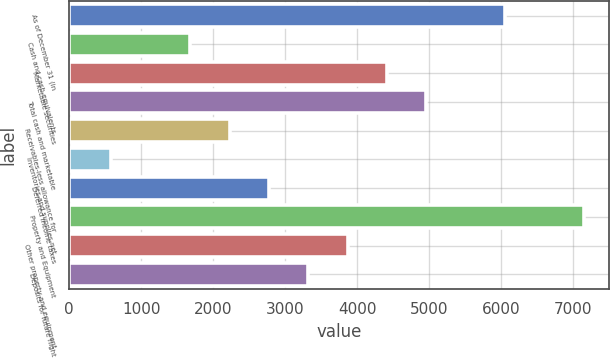<chart> <loc_0><loc_0><loc_500><loc_500><bar_chart><fcel>As of December 31 (in<fcel>Cash and cash equivalents<fcel>Marketable securities<fcel>Total cash and marketable<fcel>Receivables-less allowance for<fcel>Inventories and supplies-net<fcel>Deferred income taxes<fcel>Property and Equipment<fcel>Other property and equipment<fcel>Deposits for future flight<nl><fcel>6051.6<fcel>1678.8<fcel>4411.8<fcel>4958.4<fcel>2225.4<fcel>585.6<fcel>2772<fcel>7144.8<fcel>3865.2<fcel>3318.6<nl></chart> 